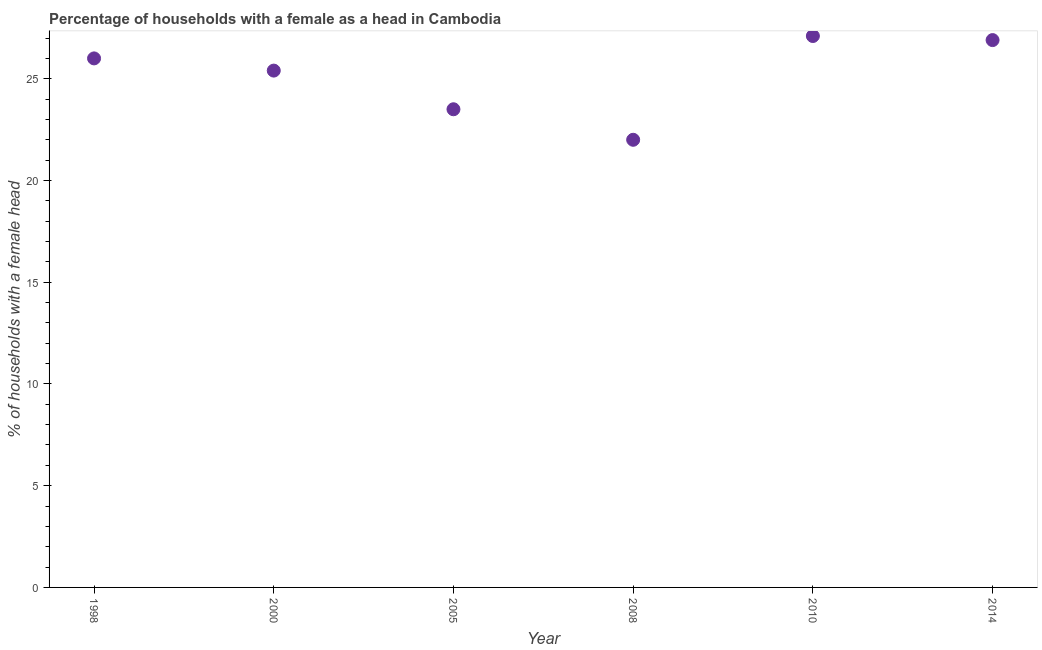Across all years, what is the maximum number of female supervised households?
Provide a short and direct response. 27.1. In which year was the number of female supervised households maximum?
Keep it short and to the point. 2010. In which year was the number of female supervised households minimum?
Offer a terse response. 2008. What is the sum of the number of female supervised households?
Your answer should be compact. 150.9. What is the difference between the number of female supervised households in 2000 and 2008?
Offer a very short reply. 3.4. What is the average number of female supervised households per year?
Offer a terse response. 25.15. What is the median number of female supervised households?
Make the answer very short. 25.7. In how many years, is the number of female supervised households greater than 14 %?
Offer a very short reply. 6. Do a majority of the years between 2014 and 2008 (inclusive) have number of female supervised households greater than 14 %?
Your response must be concise. No. What is the ratio of the number of female supervised households in 1998 to that in 2005?
Ensure brevity in your answer.  1.11. What is the difference between the highest and the second highest number of female supervised households?
Give a very brief answer. 0.2. What is the difference between the highest and the lowest number of female supervised households?
Provide a short and direct response. 5.1. Does the number of female supervised households monotonically increase over the years?
Your answer should be compact. No. How many years are there in the graph?
Keep it short and to the point. 6. What is the difference between two consecutive major ticks on the Y-axis?
Ensure brevity in your answer.  5. Are the values on the major ticks of Y-axis written in scientific E-notation?
Keep it short and to the point. No. Does the graph contain grids?
Ensure brevity in your answer.  No. What is the title of the graph?
Your answer should be compact. Percentage of households with a female as a head in Cambodia. What is the label or title of the X-axis?
Offer a very short reply. Year. What is the label or title of the Y-axis?
Provide a succinct answer. % of households with a female head. What is the % of households with a female head in 2000?
Offer a terse response. 25.4. What is the % of households with a female head in 2005?
Your answer should be very brief. 23.5. What is the % of households with a female head in 2008?
Offer a very short reply. 22. What is the % of households with a female head in 2010?
Offer a very short reply. 27.1. What is the % of households with a female head in 2014?
Ensure brevity in your answer.  26.9. What is the difference between the % of households with a female head in 1998 and 2000?
Give a very brief answer. 0.6. What is the difference between the % of households with a female head in 1998 and 2005?
Ensure brevity in your answer.  2.5. What is the difference between the % of households with a female head in 2000 and 2005?
Keep it short and to the point. 1.9. What is the difference between the % of households with a female head in 2005 and 2010?
Offer a terse response. -3.6. What is the difference between the % of households with a female head in 2008 and 2010?
Offer a terse response. -5.1. What is the difference between the % of households with a female head in 2010 and 2014?
Keep it short and to the point. 0.2. What is the ratio of the % of households with a female head in 1998 to that in 2005?
Offer a terse response. 1.11. What is the ratio of the % of households with a female head in 1998 to that in 2008?
Your answer should be compact. 1.18. What is the ratio of the % of households with a female head in 1998 to that in 2014?
Your answer should be very brief. 0.97. What is the ratio of the % of households with a female head in 2000 to that in 2005?
Offer a very short reply. 1.08. What is the ratio of the % of households with a female head in 2000 to that in 2008?
Make the answer very short. 1.16. What is the ratio of the % of households with a female head in 2000 to that in 2010?
Provide a succinct answer. 0.94. What is the ratio of the % of households with a female head in 2000 to that in 2014?
Your answer should be very brief. 0.94. What is the ratio of the % of households with a female head in 2005 to that in 2008?
Make the answer very short. 1.07. What is the ratio of the % of households with a female head in 2005 to that in 2010?
Keep it short and to the point. 0.87. What is the ratio of the % of households with a female head in 2005 to that in 2014?
Ensure brevity in your answer.  0.87. What is the ratio of the % of households with a female head in 2008 to that in 2010?
Make the answer very short. 0.81. What is the ratio of the % of households with a female head in 2008 to that in 2014?
Offer a terse response. 0.82. What is the ratio of the % of households with a female head in 2010 to that in 2014?
Your response must be concise. 1.01. 